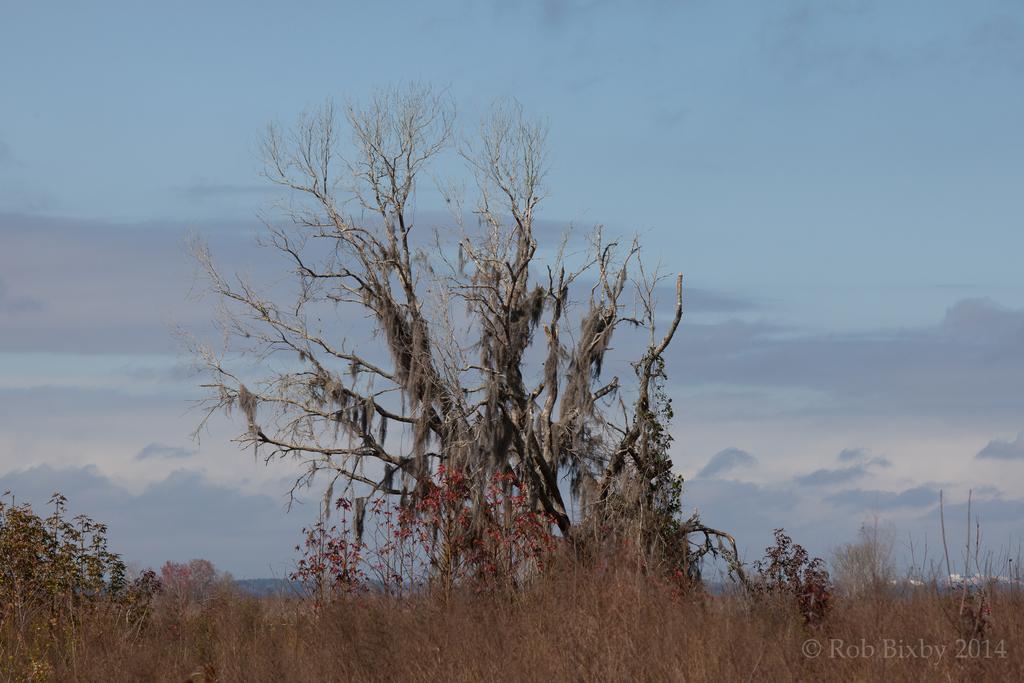In one or two sentences, can you explain what this image depicts? In the center of the image seen can see the trees. On the right side of the image we can see some buildings. In the bottom right corner we can see some text. At the top of the image we can see the clouds are present in the sky. 